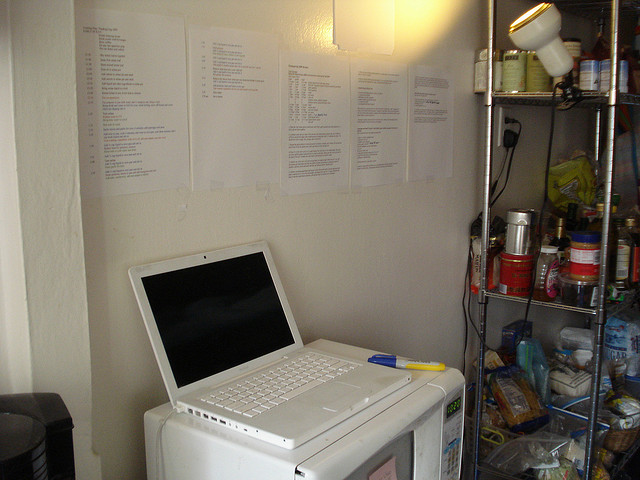If you could add one futuristic device to this setup, what would it be and why? I would add a multi-functional robotic assistant. This device would perform tasks ranging from meal preparation and household cleaning to providing reminders and organizing work schedules. Its integration with the laptop would enhance productivity, offering AI-driven insights and real-time data management. Essentially, this futuristic device would bridge the gap between convenience and efficiency, elevating the entire experience of living and working in this compact space. 